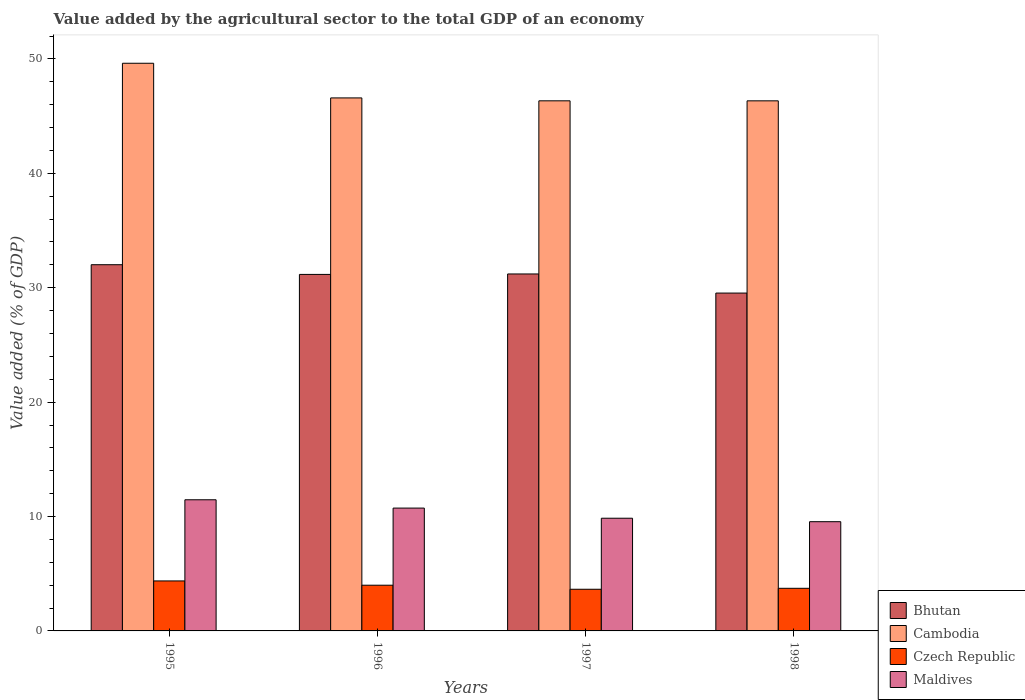How many different coloured bars are there?
Provide a short and direct response. 4. Are the number of bars per tick equal to the number of legend labels?
Keep it short and to the point. Yes. Are the number of bars on each tick of the X-axis equal?
Provide a succinct answer. Yes. How many bars are there on the 3rd tick from the left?
Make the answer very short. 4. What is the value added by the agricultural sector to the total GDP in Czech Republic in 1995?
Provide a succinct answer. 4.37. Across all years, what is the maximum value added by the agricultural sector to the total GDP in Maldives?
Provide a succinct answer. 11.46. Across all years, what is the minimum value added by the agricultural sector to the total GDP in Bhutan?
Ensure brevity in your answer.  29.53. What is the total value added by the agricultural sector to the total GDP in Czech Republic in the graph?
Your answer should be very brief. 15.73. What is the difference between the value added by the agricultural sector to the total GDP in Czech Republic in 1995 and that in 1998?
Give a very brief answer. 0.64. What is the difference between the value added by the agricultural sector to the total GDP in Bhutan in 1997 and the value added by the agricultural sector to the total GDP in Cambodia in 1995?
Your answer should be very brief. -18.42. What is the average value added by the agricultural sector to the total GDP in Maldives per year?
Make the answer very short. 10.4. In the year 1997, what is the difference between the value added by the agricultural sector to the total GDP in Cambodia and value added by the agricultural sector to the total GDP in Bhutan?
Your response must be concise. 15.14. What is the ratio of the value added by the agricultural sector to the total GDP in Bhutan in 1995 to that in 1996?
Ensure brevity in your answer.  1.03. What is the difference between the highest and the second highest value added by the agricultural sector to the total GDP in Czech Republic?
Provide a short and direct response. 0.37. What is the difference between the highest and the lowest value added by the agricultural sector to the total GDP in Czech Republic?
Provide a short and direct response. 0.73. What does the 1st bar from the left in 1995 represents?
Your answer should be very brief. Bhutan. What does the 1st bar from the right in 1998 represents?
Give a very brief answer. Maldives. Are all the bars in the graph horizontal?
Provide a short and direct response. No. Are the values on the major ticks of Y-axis written in scientific E-notation?
Keep it short and to the point. No. Does the graph contain any zero values?
Ensure brevity in your answer.  No. Where does the legend appear in the graph?
Offer a terse response. Bottom right. How many legend labels are there?
Your response must be concise. 4. How are the legend labels stacked?
Ensure brevity in your answer.  Vertical. What is the title of the graph?
Your answer should be compact. Value added by the agricultural sector to the total GDP of an economy. Does "Canada" appear as one of the legend labels in the graph?
Give a very brief answer. No. What is the label or title of the X-axis?
Your answer should be very brief. Years. What is the label or title of the Y-axis?
Offer a very short reply. Value added (% of GDP). What is the Value added (% of GDP) of Bhutan in 1995?
Make the answer very short. 32.01. What is the Value added (% of GDP) of Cambodia in 1995?
Make the answer very short. 49.62. What is the Value added (% of GDP) in Czech Republic in 1995?
Your answer should be compact. 4.37. What is the Value added (% of GDP) of Maldives in 1995?
Your answer should be very brief. 11.46. What is the Value added (% of GDP) in Bhutan in 1996?
Your answer should be compact. 31.16. What is the Value added (% of GDP) in Cambodia in 1996?
Your response must be concise. 46.59. What is the Value added (% of GDP) of Czech Republic in 1996?
Make the answer very short. 4. What is the Value added (% of GDP) of Maldives in 1996?
Ensure brevity in your answer.  10.74. What is the Value added (% of GDP) in Bhutan in 1997?
Your answer should be compact. 31.2. What is the Value added (% of GDP) in Cambodia in 1997?
Keep it short and to the point. 46.34. What is the Value added (% of GDP) of Czech Republic in 1997?
Your response must be concise. 3.64. What is the Value added (% of GDP) in Maldives in 1997?
Your response must be concise. 9.85. What is the Value added (% of GDP) of Bhutan in 1998?
Give a very brief answer. 29.53. What is the Value added (% of GDP) of Cambodia in 1998?
Offer a very short reply. 46.34. What is the Value added (% of GDP) of Czech Republic in 1998?
Offer a very short reply. 3.72. What is the Value added (% of GDP) in Maldives in 1998?
Offer a very short reply. 9.55. Across all years, what is the maximum Value added (% of GDP) of Bhutan?
Offer a very short reply. 32.01. Across all years, what is the maximum Value added (% of GDP) in Cambodia?
Provide a succinct answer. 49.62. Across all years, what is the maximum Value added (% of GDP) in Czech Republic?
Offer a terse response. 4.37. Across all years, what is the maximum Value added (% of GDP) in Maldives?
Your response must be concise. 11.46. Across all years, what is the minimum Value added (% of GDP) of Bhutan?
Give a very brief answer. 29.53. Across all years, what is the minimum Value added (% of GDP) in Cambodia?
Make the answer very short. 46.34. Across all years, what is the minimum Value added (% of GDP) of Czech Republic?
Provide a succinct answer. 3.64. Across all years, what is the minimum Value added (% of GDP) of Maldives?
Provide a short and direct response. 9.55. What is the total Value added (% of GDP) in Bhutan in the graph?
Offer a terse response. 123.91. What is the total Value added (% of GDP) in Cambodia in the graph?
Offer a very short reply. 188.89. What is the total Value added (% of GDP) in Czech Republic in the graph?
Your response must be concise. 15.73. What is the total Value added (% of GDP) in Maldives in the graph?
Offer a terse response. 41.6. What is the difference between the Value added (% of GDP) of Bhutan in 1995 and that in 1996?
Give a very brief answer. 0.85. What is the difference between the Value added (% of GDP) of Cambodia in 1995 and that in 1996?
Your response must be concise. 3.03. What is the difference between the Value added (% of GDP) of Czech Republic in 1995 and that in 1996?
Your answer should be compact. 0.37. What is the difference between the Value added (% of GDP) of Maldives in 1995 and that in 1996?
Give a very brief answer. 0.73. What is the difference between the Value added (% of GDP) of Bhutan in 1995 and that in 1997?
Your answer should be compact. 0.81. What is the difference between the Value added (% of GDP) of Cambodia in 1995 and that in 1997?
Ensure brevity in your answer.  3.28. What is the difference between the Value added (% of GDP) in Czech Republic in 1995 and that in 1997?
Provide a succinct answer. 0.73. What is the difference between the Value added (% of GDP) of Maldives in 1995 and that in 1997?
Your answer should be compact. 1.61. What is the difference between the Value added (% of GDP) in Bhutan in 1995 and that in 1998?
Offer a very short reply. 2.48. What is the difference between the Value added (% of GDP) of Cambodia in 1995 and that in 1998?
Your answer should be very brief. 3.28. What is the difference between the Value added (% of GDP) in Czech Republic in 1995 and that in 1998?
Provide a succinct answer. 0.64. What is the difference between the Value added (% of GDP) in Maldives in 1995 and that in 1998?
Offer a very short reply. 1.92. What is the difference between the Value added (% of GDP) in Bhutan in 1996 and that in 1997?
Your answer should be compact. -0.04. What is the difference between the Value added (% of GDP) of Cambodia in 1996 and that in 1997?
Your answer should be very brief. 0.25. What is the difference between the Value added (% of GDP) in Czech Republic in 1996 and that in 1997?
Offer a terse response. 0.35. What is the difference between the Value added (% of GDP) in Maldives in 1996 and that in 1997?
Offer a very short reply. 0.89. What is the difference between the Value added (% of GDP) in Bhutan in 1996 and that in 1998?
Give a very brief answer. 1.63. What is the difference between the Value added (% of GDP) in Cambodia in 1996 and that in 1998?
Ensure brevity in your answer.  0.25. What is the difference between the Value added (% of GDP) in Czech Republic in 1996 and that in 1998?
Your response must be concise. 0.27. What is the difference between the Value added (% of GDP) of Maldives in 1996 and that in 1998?
Your response must be concise. 1.19. What is the difference between the Value added (% of GDP) of Bhutan in 1997 and that in 1998?
Your answer should be very brief. 1.67. What is the difference between the Value added (% of GDP) in Cambodia in 1997 and that in 1998?
Offer a very short reply. 0. What is the difference between the Value added (% of GDP) in Czech Republic in 1997 and that in 1998?
Keep it short and to the point. -0.08. What is the difference between the Value added (% of GDP) of Maldives in 1997 and that in 1998?
Your answer should be very brief. 0.3. What is the difference between the Value added (% of GDP) in Bhutan in 1995 and the Value added (% of GDP) in Cambodia in 1996?
Provide a succinct answer. -14.58. What is the difference between the Value added (% of GDP) of Bhutan in 1995 and the Value added (% of GDP) of Czech Republic in 1996?
Your response must be concise. 28.02. What is the difference between the Value added (% of GDP) of Bhutan in 1995 and the Value added (% of GDP) of Maldives in 1996?
Keep it short and to the point. 21.27. What is the difference between the Value added (% of GDP) of Cambodia in 1995 and the Value added (% of GDP) of Czech Republic in 1996?
Provide a short and direct response. 45.63. What is the difference between the Value added (% of GDP) of Cambodia in 1995 and the Value added (% of GDP) of Maldives in 1996?
Your response must be concise. 38.88. What is the difference between the Value added (% of GDP) of Czech Republic in 1995 and the Value added (% of GDP) of Maldives in 1996?
Provide a succinct answer. -6.37. What is the difference between the Value added (% of GDP) in Bhutan in 1995 and the Value added (% of GDP) in Cambodia in 1997?
Keep it short and to the point. -14.33. What is the difference between the Value added (% of GDP) in Bhutan in 1995 and the Value added (% of GDP) in Czech Republic in 1997?
Ensure brevity in your answer.  28.37. What is the difference between the Value added (% of GDP) in Bhutan in 1995 and the Value added (% of GDP) in Maldives in 1997?
Your answer should be very brief. 22.16. What is the difference between the Value added (% of GDP) of Cambodia in 1995 and the Value added (% of GDP) of Czech Republic in 1997?
Your answer should be very brief. 45.98. What is the difference between the Value added (% of GDP) in Cambodia in 1995 and the Value added (% of GDP) in Maldives in 1997?
Offer a very short reply. 39.77. What is the difference between the Value added (% of GDP) of Czech Republic in 1995 and the Value added (% of GDP) of Maldives in 1997?
Keep it short and to the point. -5.48. What is the difference between the Value added (% of GDP) in Bhutan in 1995 and the Value added (% of GDP) in Cambodia in 1998?
Ensure brevity in your answer.  -14.33. What is the difference between the Value added (% of GDP) of Bhutan in 1995 and the Value added (% of GDP) of Czech Republic in 1998?
Ensure brevity in your answer.  28.29. What is the difference between the Value added (% of GDP) in Bhutan in 1995 and the Value added (% of GDP) in Maldives in 1998?
Make the answer very short. 22.46. What is the difference between the Value added (% of GDP) of Cambodia in 1995 and the Value added (% of GDP) of Czech Republic in 1998?
Ensure brevity in your answer.  45.9. What is the difference between the Value added (% of GDP) in Cambodia in 1995 and the Value added (% of GDP) in Maldives in 1998?
Keep it short and to the point. 40.07. What is the difference between the Value added (% of GDP) of Czech Republic in 1995 and the Value added (% of GDP) of Maldives in 1998?
Your response must be concise. -5.18. What is the difference between the Value added (% of GDP) of Bhutan in 1996 and the Value added (% of GDP) of Cambodia in 1997?
Keep it short and to the point. -15.17. What is the difference between the Value added (% of GDP) of Bhutan in 1996 and the Value added (% of GDP) of Czech Republic in 1997?
Provide a short and direct response. 27.52. What is the difference between the Value added (% of GDP) in Bhutan in 1996 and the Value added (% of GDP) in Maldives in 1997?
Keep it short and to the point. 21.31. What is the difference between the Value added (% of GDP) of Cambodia in 1996 and the Value added (% of GDP) of Czech Republic in 1997?
Keep it short and to the point. 42.95. What is the difference between the Value added (% of GDP) of Cambodia in 1996 and the Value added (% of GDP) of Maldives in 1997?
Your answer should be compact. 36.74. What is the difference between the Value added (% of GDP) in Czech Republic in 1996 and the Value added (% of GDP) in Maldives in 1997?
Provide a short and direct response. -5.86. What is the difference between the Value added (% of GDP) of Bhutan in 1996 and the Value added (% of GDP) of Cambodia in 1998?
Your answer should be compact. -15.17. What is the difference between the Value added (% of GDP) in Bhutan in 1996 and the Value added (% of GDP) in Czech Republic in 1998?
Provide a succinct answer. 27.44. What is the difference between the Value added (% of GDP) in Bhutan in 1996 and the Value added (% of GDP) in Maldives in 1998?
Give a very brief answer. 21.62. What is the difference between the Value added (% of GDP) in Cambodia in 1996 and the Value added (% of GDP) in Czech Republic in 1998?
Provide a short and direct response. 42.87. What is the difference between the Value added (% of GDP) of Cambodia in 1996 and the Value added (% of GDP) of Maldives in 1998?
Offer a very short reply. 37.04. What is the difference between the Value added (% of GDP) in Czech Republic in 1996 and the Value added (% of GDP) in Maldives in 1998?
Give a very brief answer. -5.55. What is the difference between the Value added (% of GDP) of Bhutan in 1997 and the Value added (% of GDP) of Cambodia in 1998?
Make the answer very short. -15.13. What is the difference between the Value added (% of GDP) in Bhutan in 1997 and the Value added (% of GDP) in Czech Republic in 1998?
Keep it short and to the point. 27.48. What is the difference between the Value added (% of GDP) of Bhutan in 1997 and the Value added (% of GDP) of Maldives in 1998?
Your response must be concise. 21.65. What is the difference between the Value added (% of GDP) of Cambodia in 1997 and the Value added (% of GDP) of Czech Republic in 1998?
Give a very brief answer. 42.61. What is the difference between the Value added (% of GDP) in Cambodia in 1997 and the Value added (% of GDP) in Maldives in 1998?
Your response must be concise. 36.79. What is the difference between the Value added (% of GDP) of Czech Republic in 1997 and the Value added (% of GDP) of Maldives in 1998?
Provide a succinct answer. -5.91. What is the average Value added (% of GDP) in Bhutan per year?
Your response must be concise. 30.98. What is the average Value added (% of GDP) of Cambodia per year?
Your response must be concise. 47.22. What is the average Value added (% of GDP) of Czech Republic per year?
Provide a short and direct response. 3.93. In the year 1995, what is the difference between the Value added (% of GDP) in Bhutan and Value added (% of GDP) in Cambodia?
Keep it short and to the point. -17.61. In the year 1995, what is the difference between the Value added (% of GDP) in Bhutan and Value added (% of GDP) in Czech Republic?
Provide a succinct answer. 27.64. In the year 1995, what is the difference between the Value added (% of GDP) in Bhutan and Value added (% of GDP) in Maldives?
Provide a short and direct response. 20.55. In the year 1995, what is the difference between the Value added (% of GDP) of Cambodia and Value added (% of GDP) of Czech Republic?
Provide a short and direct response. 45.25. In the year 1995, what is the difference between the Value added (% of GDP) of Cambodia and Value added (% of GDP) of Maldives?
Your answer should be very brief. 38.16. In the year 1995, what is the difference between the Value added (% of GDP) of Czech Republic and Value added (% of GDP) of Maldives?
Provide a short and direct response. -7.09. In the year 1996, what is the difference between the Value added (% of GDP) in Bhutan and Value added (% of GDP) in Cambodia?
Your answer should be compact. -15.43. In the year 1996, what is the difference between the Value added (% of GDP) of Bhutan and Value added (% of GDP) of Czech Republic?
Ensure brevity in your answer.  27.17. In the year 1996, what is the difference between the Value added (% of GDP) in Bhutan and Value added (% of GDP) in Maldives?
Provide a short and direct response. 20.43. In the year 1996, what is the difference between the Value added (% of GDP) of Cambodia and Value added (% of GDP) of Czech Republic?
Provide a succinct answer. 42.6. In the year 1996, what is the difference between the Value added (% of GDP) in Cambodia and Value added (% of GDP) in Maldives?
Offer a very short reply. 35.85. In the year 1996, what is the difference between the Value added (% of GDP) in Czech Republic and Value added (% of GDP) in Maldives?
Ensure brevity in your answer.  -6.74. In the year 1997, what is the difference between the Value added (% of GDP) of Bhutan and Value added (% of GDP) of Cambodia?
Provide a succinct answer. -15.14. In the year 1997, what is the difference between the Value added (% of GDP) in Bhutan and Value added (% of GDP) in Czech Republic?
Ensure brevity in your answer.  27.56. In the year 1997, what is the difference between the Value added (% of GDP) of Bhutan and Value added (% of GDP) of Maldives?
Your response must be concise. 21.35. In the year 1997, what is the difference between the Value added (% of GDP) in Cambodia and Value added (% of GDP) in Czech Republic?
Your answer should be very brief. 42.7. In the year 1997, what is the difference between the Value added (% of GDP) of Cambodia and Value added (% of GDP) of Maldives?
Make the answer very short. 36.49. In the year 1997, what is the difference between the Value added (% of GDP) of Czech Republic and Value added (% of GDP) of Maldives?
Your response must be concise. -6.21. In the year 1998, what is the difference between the Value added (% of GDP) of Bhutan and Value added (% of GDP) of Cambodia?
Keep it short and to the point. -16.8. In the year 1998, what is the difference between the Value added (% of GDP) in Bhutan and Value added (% of GDP) in Czech Republic?
Keep it short and to the point. 25.81. In the year 1998, what is the difference between the Value added (% of GDP) of Bhutan and Value added (% of GDP) of Maldives?
Offer a terse response. 19.98. In the year 1998, what is the difference between the Value added (% of GDP) of Cambodia and Value added (% of GDP) of Czech Republic?
Offer a terse response. 42.61. In the year 1998, what is the difference between the Value added (% of GDP) of Cambodia and Value added (% of GDP) of Maldives?
Make the answer very short. 36.79. In the year 1998, what is the difference between the Value added (% of GDP) of Czech Republic and Value added (% of GDP) of Maldives?
Provide a short and direct response. -5.82. What is the ratio of the Value added (% of GDP) of Bhutan in 1995 to that in 1996?
Your answer should be very brief. 1.03. What is the ratio of the Value added (% of GDP) in Cambodia in 1995 to that in 1996?
Provide a succinct answer. 1.06. What is the ratio of the Value added (% of GDP) of Czech Republic in 1995 to that in 1996?
Your answer should be compact. 1.09. What is the ratio of the Value added (% of GDP) in Maldives in 1995 to that in 1996?
Your answer should be compact. 1.07. What is the ratio of the Value added (% of GDP) of Bhutan in 1995 to that in 1997?
Offer a very short reply. 1.03. What is the ratio of the Value added (% of GDP) of Cambodia in 1995 to that in 1997?
Your response must be concise. 1.07. What is the ratio of the Value added (% of GDP) of Czech Republic in 1995 to that in 1997?
Offer a very short reply. 1.2. What is the ratio of the Value added (% of GDP) of Maldives in 1995 to that in 1997?
Offer a terse response. 1.16. What is the ratio of the Value added (% of GDP) of Bhutan in 1995 to that in 1998?
Keep it short and to the point. 1.08. What is the ratio of the Value added (% of GDP) in Cambodia in 1995 to that in 1998?
Keep it short and to the point. 1.07. What is the ratio of the Value added (% of GDP) in Czech Republic in 1995 to that in 1998?
Give a very brief answer. 1.17. What is the ratio of the Value added (% of GDP) in Maldives in 1995 to that in 1998?
Offer a terse response. 1.2. What is the ratio of the Value added (% of GDP) of Bhutan in 1996 to that in 1997?
Offer a very short reply. 1. What is the ratio of the Value added (% of GDP) in Czech Republic in 1996 to that in 1997?
Provide a succinct answer. 1.1. What is the ratio of the Value added (% of GDP) in Maldives in 1996 to that in 1997?
Keep it short and to the point. 1.09. What is the ratio of the Value added (% of GDP) in Bhutan in 1996 to that in 1998?
Make the answer very short. 1.06. What is the ratio of the Value added (% of GDP) in Cambodia in 1996 to that in 1998?
Offer a terse response. 1.01. What is the ratio of the Value added (% of GDP) of Czech Republic in 1996 to that in 1998?
Keep it short and to the point. 1.07. What is the ratio of the Value added (% of GDP) of Maldives in 1996 to that in 1998?
Provide a short and direct response. 1.12. What is the ratio of the Value added (% of GDP) of Bhutan in 1997 to that in 1998?
Give a very brief answer. 1.06. What is the ratio of the Value added (% of GDP) in Cambodia in 1997 to that in 1998?
Provide a short and direct response. 1. What is the ratio of the Value added (% of GDP) of Czech Republic in 1997 to that in 1998?
Your answer should be very brief. 0.98. What is the ratio of the Value added (% of GDP) in Maldives in 1997 to that in 1998?
Ensure brevity in your answer.  1.03. What is the difference between the highest and the second highest Value added (% of GDP) in Bhutan?
Your answer should be compact. 0.81. What is the difference between the highest and the second highest Value added (% of GDP) of Cambodia?
Provide a succinct answer. 3.03. What is the difference between the highest and the second highest Value added (% of GDP) in Czech Republic?
Ensure brevity in your answer.  0.37. What is the difference between the highest and the second highest Value added (% of GDP) of Maldives?
Provide a short and direct response. 0.73. What is the difference between the highest and the lowest Value added (% of GDP) in Bhutan?
Keep it short and to the point. 2.48. What is the difference between the highest and the lowest Value added (% of GDP) of Cambodia?
Offer a very short reply. 3.28. What is the difference between the highest and the lowest Value added (% of GDP) in Czech Republic?
Keep it short and to the point. 0.73. What is the difference between the highest and the lowest Value added (% of GDP) of Maldives?
Offer a very short reply. 1.92. 